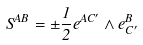<formula> <loc_0><loc_0><loc_500><loc_500>S ^ { A B } = \pm \frac { 1 } { 2 } e ^ { A C ^ { \prime } } \wedge e _ { C ^ { \prime } } ^ { B }</formula> 